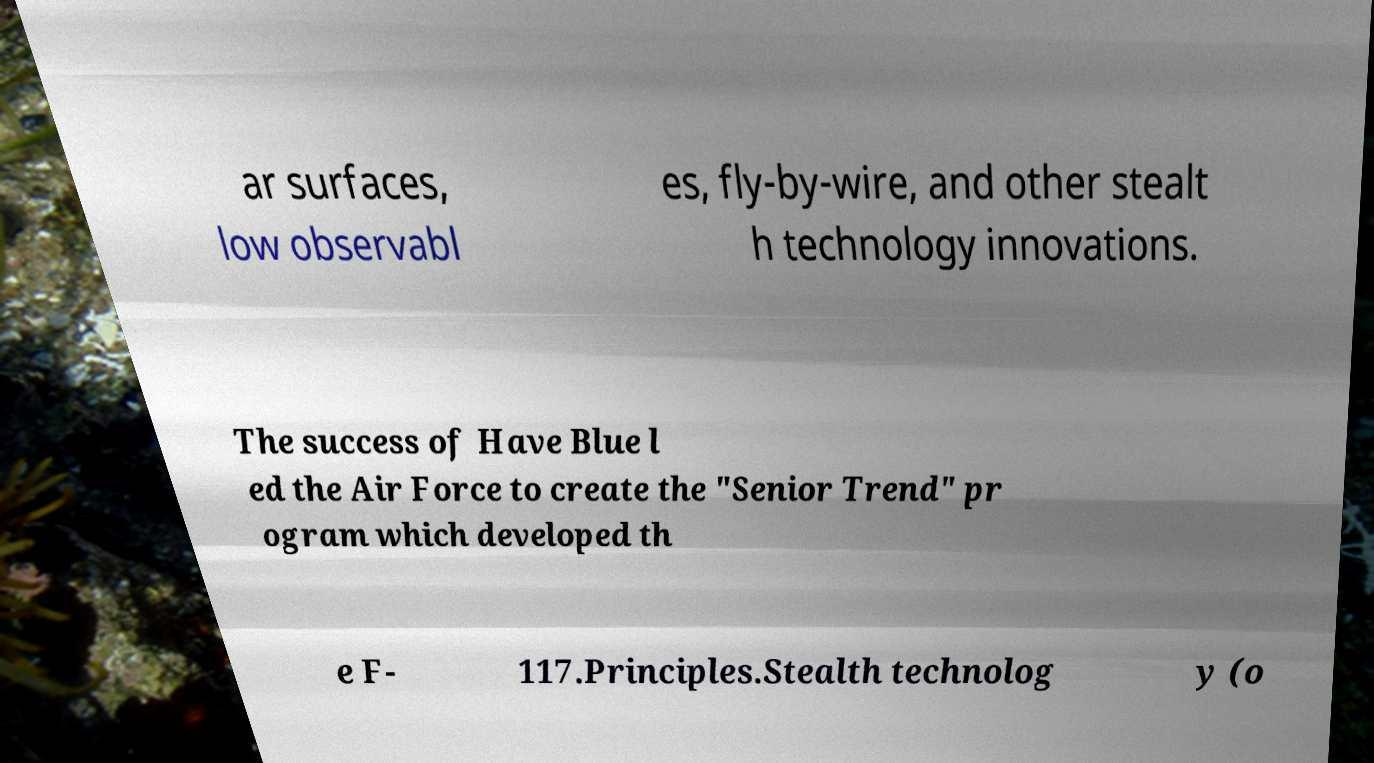I need the written content from this picture converted into text. Can you do that? ar surfaces, low observabl es, fly-by-wire, and other stealt h technology innovations. The success of Have Blue l ed the Air Force to create the "Senior Trend" pr ogram which developed th e F- 117.Principles.Stealth technolog y (o 